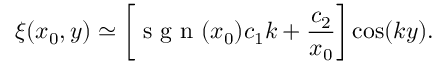Convert formula to latex. <formula><loc_0><loc_0><loc_500><loc_500>\xi ( x _ { 0 } , y ) \simeq \left [ s g n ( x _ { 0 } ) c _ { 1 } k + \frac { c _ { 2 } } { x _ { 0 } } \right ] \cos ( k y ) .</formula> 